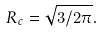<formula> <loc_0><loc_0><loc_500><loc_500>R _ { c } = \sqrt { 3 / 2 \pi } .</formula> 